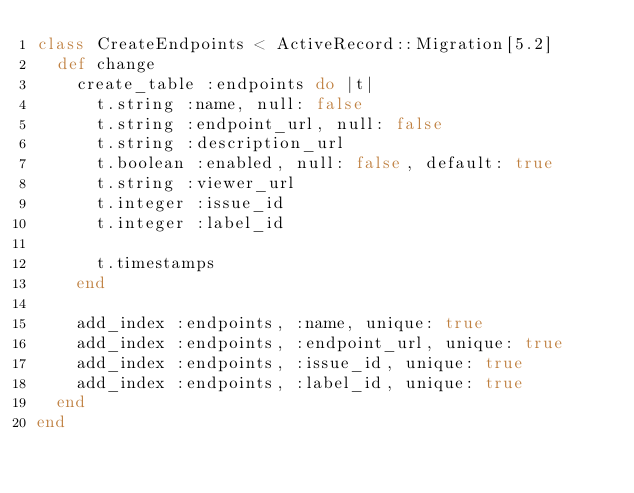Convert code to text. <code><loc_0><loc_0><loc_500><loc_500><_Ruby_>class CreateEndpoints < ActiveRecord::Migration[5.2]
  def change
    create_table :endpoints do |t|
      t.string :name, null: false
      t.string :endpoint_url, null: false
      t.string :description_url
      t.boolean :enabled, null: false, default: true
      t.string :viewer_url
      t.integer :issue_id
      t.integer :label_id

      t.timestamps
    end

    add_index :endpoints, :name, unique: true
    add_index :endpoints, :endpoint_url, unique: true
    add_index :endpoints, :issue_id, unique: true
    add_index :endpoints, :label_id, unique: true
  end
end
</code> 